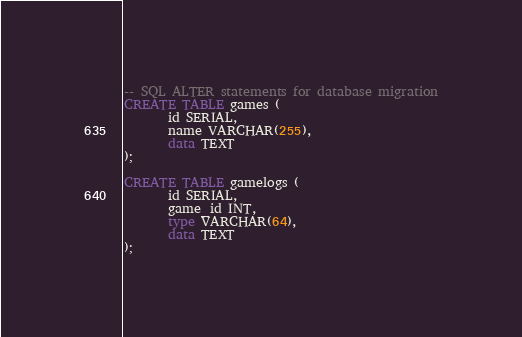Convert code to text. <code><loc_0><loc_0><loc_500><loc_500><_SQL_>-- SQL ALTER statements for database migration
CREATE TABLE games (
       id SERIAL,
       name VARCHAR(255),
       data TEXT
);

CREATE TABLE gamelogs (
       id SERIAL,
       game_id INT,
       type VARCHAR(64),
       data TEXT
);
</code> 